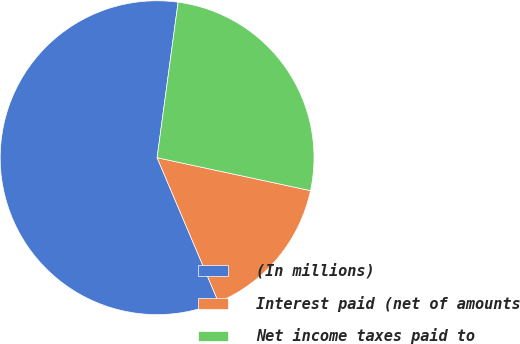<chart> <loc_0><loc_0><loc_500><loc_500><pie_chart><fcel>(In millions)<fcel>Interest paid (net of amounts<fcel>Net income taxes paid to<nl><fcel>58.53%<fcel>15.24%<fcel>26.23%<nl></chart> 